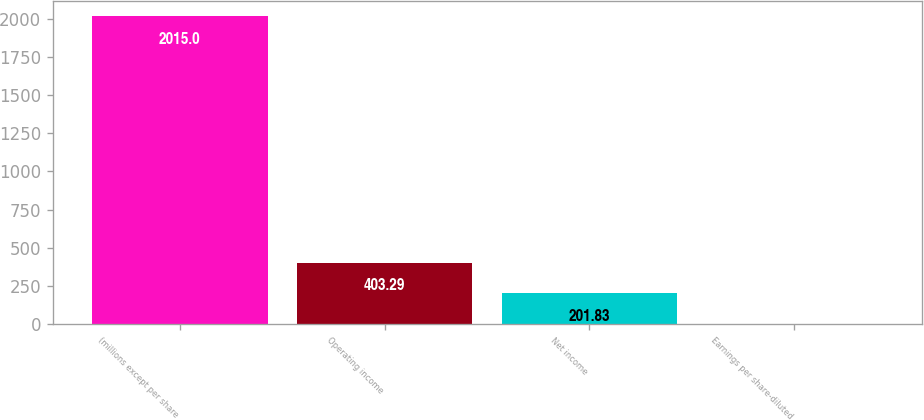Convert chart. <chart><loc_0><loc_0><loc_500><loc_500><bar_chart><fcel>(millions except per share<fcel>Operating income<fcel>Net income<fcel>Earnings per share-diluted<nl><fcel>2015<fcel>403.29<fcel>201.83<fcel>0.37<nl></chart> 